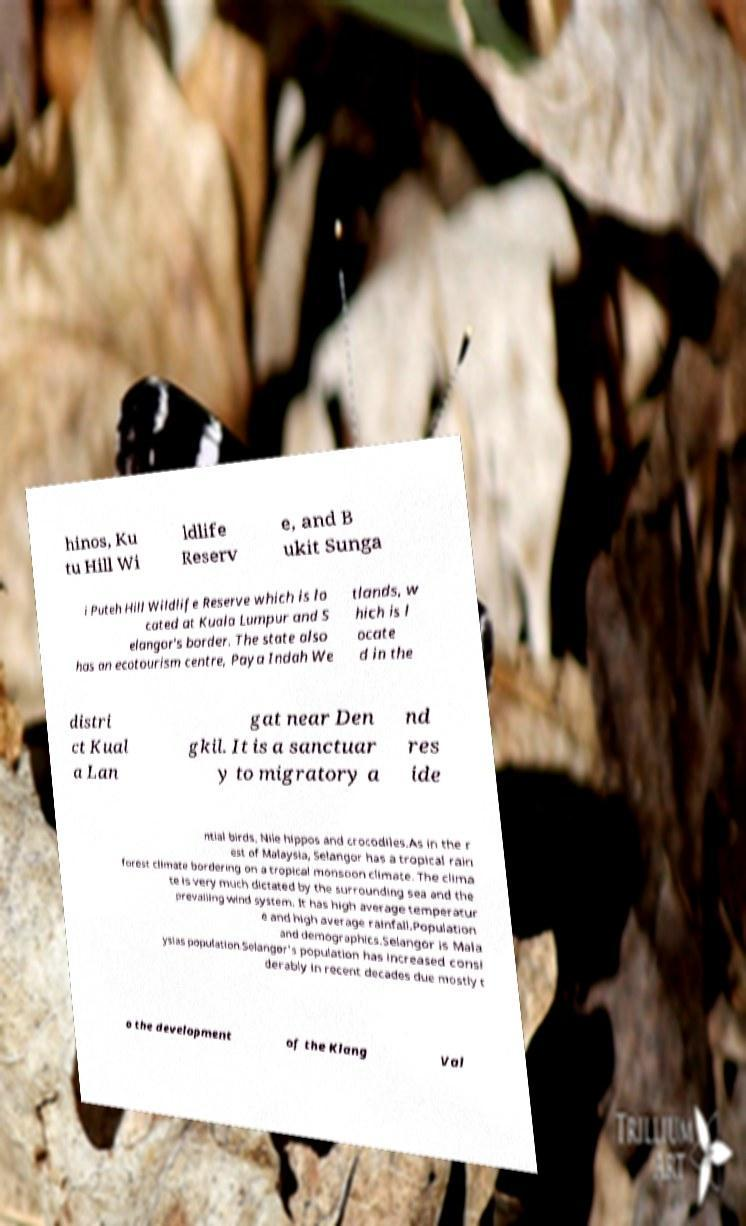Could you extract and type out the text from this image? hinos, Ku tu Hill Wi ldlife Reserv e, and B ukit Sunga i Puteh Hill Wildlife Reserve which is lo cated at Kuala Lumpur and S elangor's border. The state also has an ecotourism centre, Paya Indah We tlands, w hich is l ocate d in the distri ct Kual a Lan gat near Den gkil. It is a sanctuar y to migratory a nd res ide ntial birds, Nile hippos and crocodiles.As in the r est of Malaysia, Selangor has a tropical rain forest climate bordering on a tropical monsoon climate. The clima te is very much dictated by the surrounding sea and the prevailing wind system. It has high average temperatur e and high average rainfall.Population and demographics.Selangor is Mala ysias population.Selangor's population has increased consi derably in recent decades due mostly t o the development of the Klang Val 